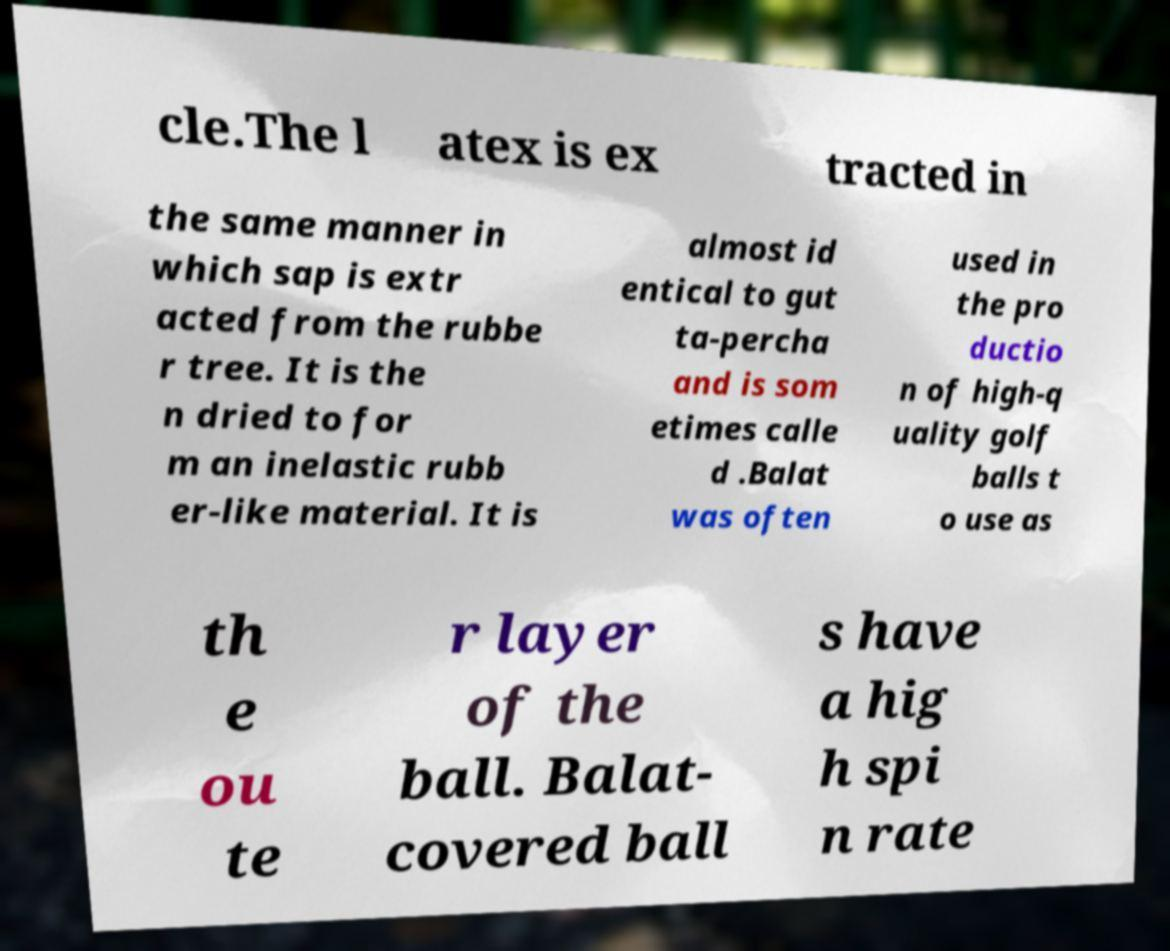For documentation purposes, I need the text within this image transcribed. Could you provide that? cle.The l atex is ex tracted in the same manner in which sap is extr acted from the rubbe r tree. It is the n dried to for m an inelastic rubb er-like material. It is almost id entical to gut ta-percha and is som etimes calle d .Balat was often used in the pro ductio n of high-q uality golf balls t o use as th e ou te r layer of the ball. Balat- covered ball s have a hig h spi n rate 